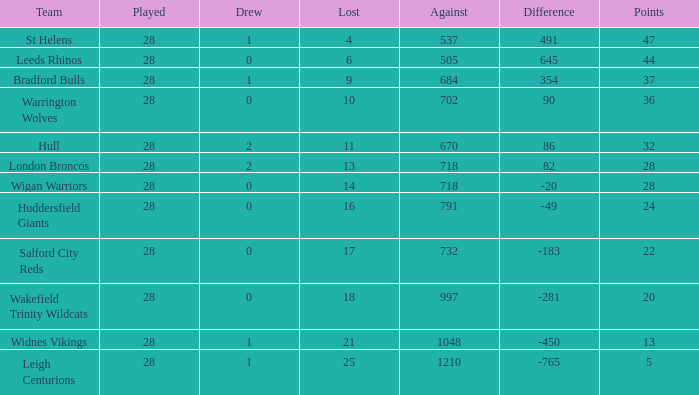What is the highest difference for the team that had less than 0 draws? None. 